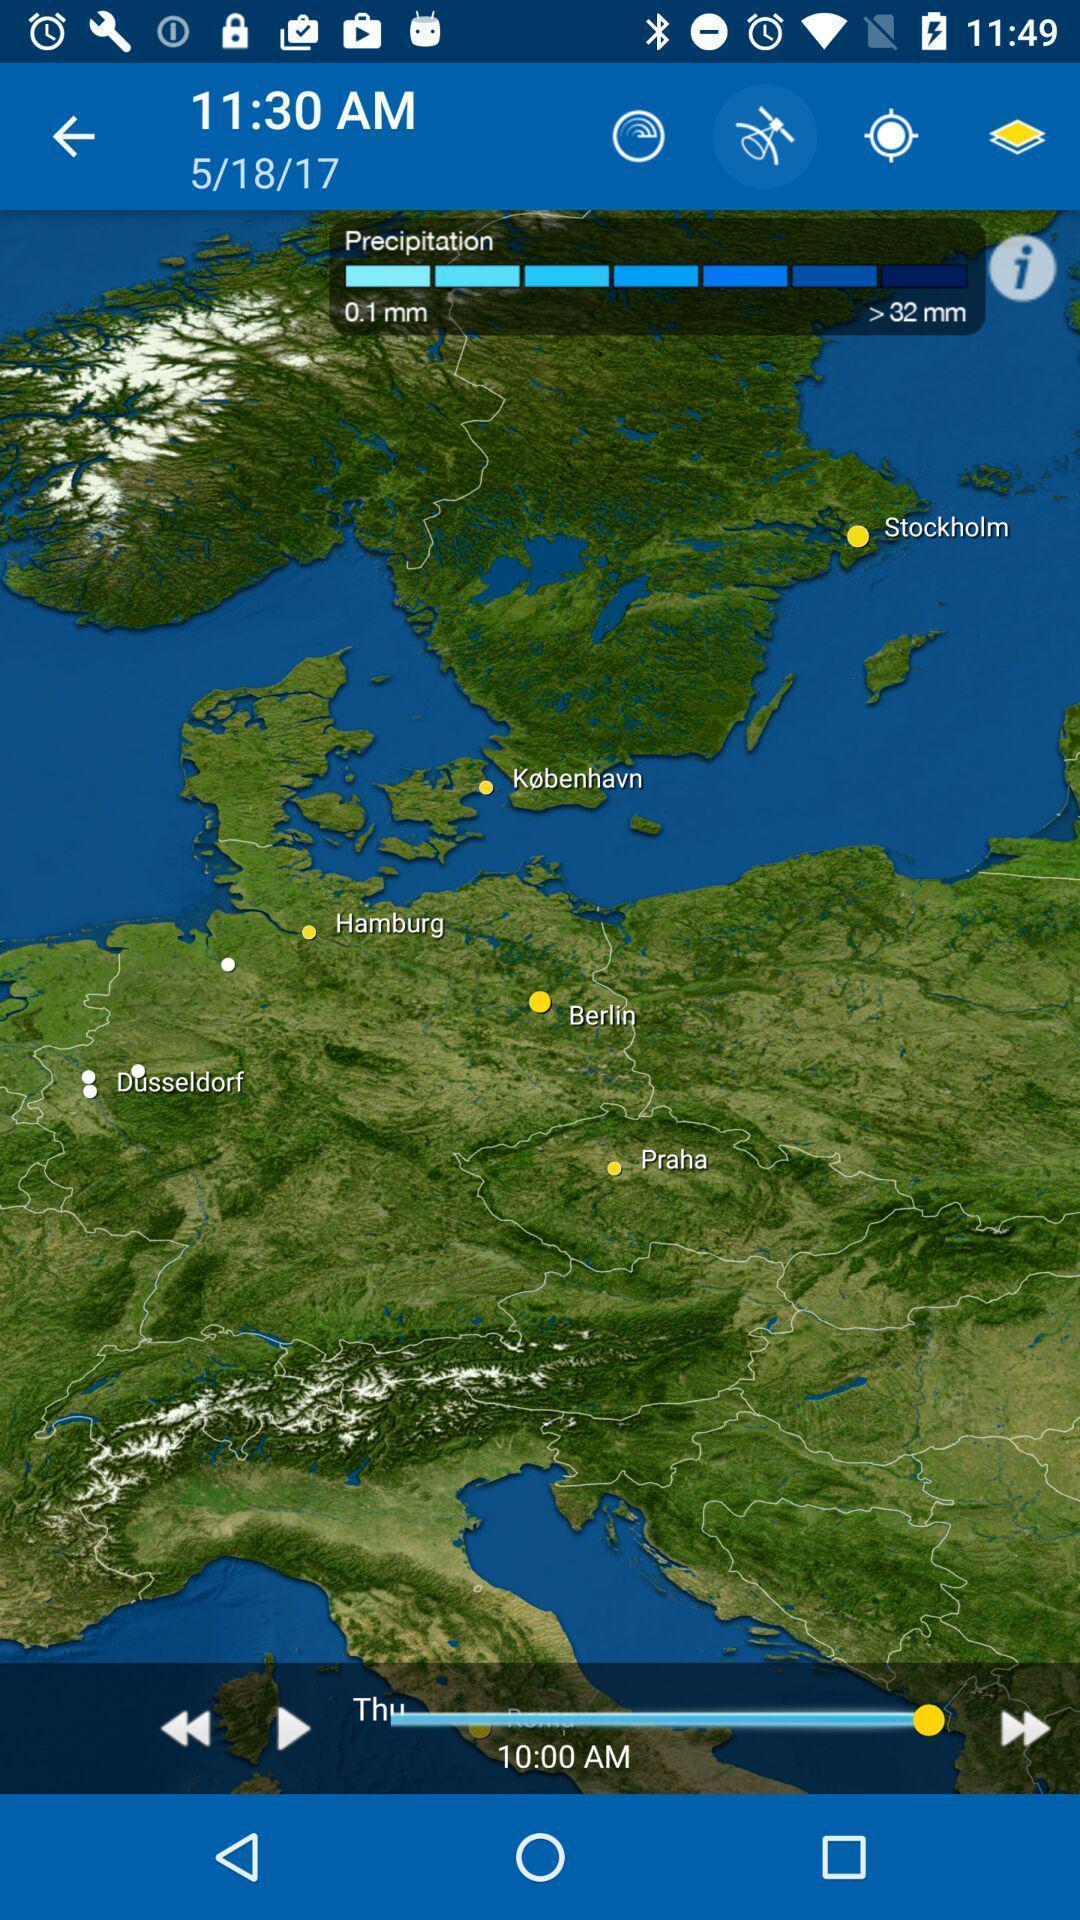Tell me about the visual elements in this screen capture. Screen displaying the weather conditions of a location. 